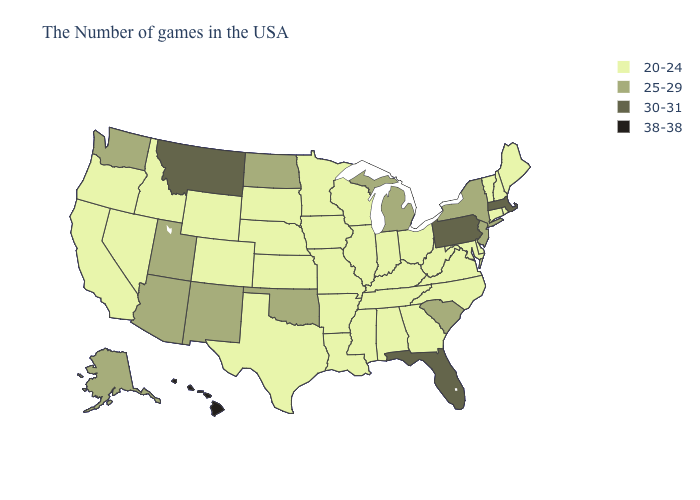Does the first symbol in the legend represent the smallest category?
Keep it brief. Yes. Does Maine have the highest value in the USA?
Give a very brief answer. No. Name the states that have a value in the range 20-24?
Write a very short answer. Maine, Rhode Island, New Hampshire, Vermont, Connecticut, Delaware, Maryland, Virginia, North Carolina, West Virginia, Ohio, Georgia, Kentucky, Indiana, Alabama, Tennessee, Wisconsin, Illinois, Mississippi, Louisiana, Missouri, Arkansas, Minnesota, Iowa, Kansas, Nebraska, Texas, South Dakota, Wyoming, Colorado, Idaho, Nevada, California, Oregon. What is the highest value in states that border Illinois?
Write a very short answer. 20-24. What is the value of Oregon?
Give a very brief answer. 20-24. Is the legend a continuous bar?
Short answer required. No. What is the value of Delaware?
Answer briefly. 20-24. Name the states that have a value in the range 30-31?
Concise answer only. Massachusetts, Pennsylvania, Florida, Montana. Name the states that have a value in the range 38-38?
Answer briefly. Hawaii. What is the value of Rhode Island?
Write a very short answer. 20-24. Does New York have a lower value than Hawaii?
Answer briefly. Yes. How many symbols are there in the legend?
Concise answer only. 4. Name the states that have a value in the range 30-31?
Write a very short answer. Massachusetts, Pennsylvania, Florida, Montana. Name the states that have a value in the range 38-38?
Write a very short answer. Hawaii. How many symbols are there in the legend?
Keep it brief. 4. 